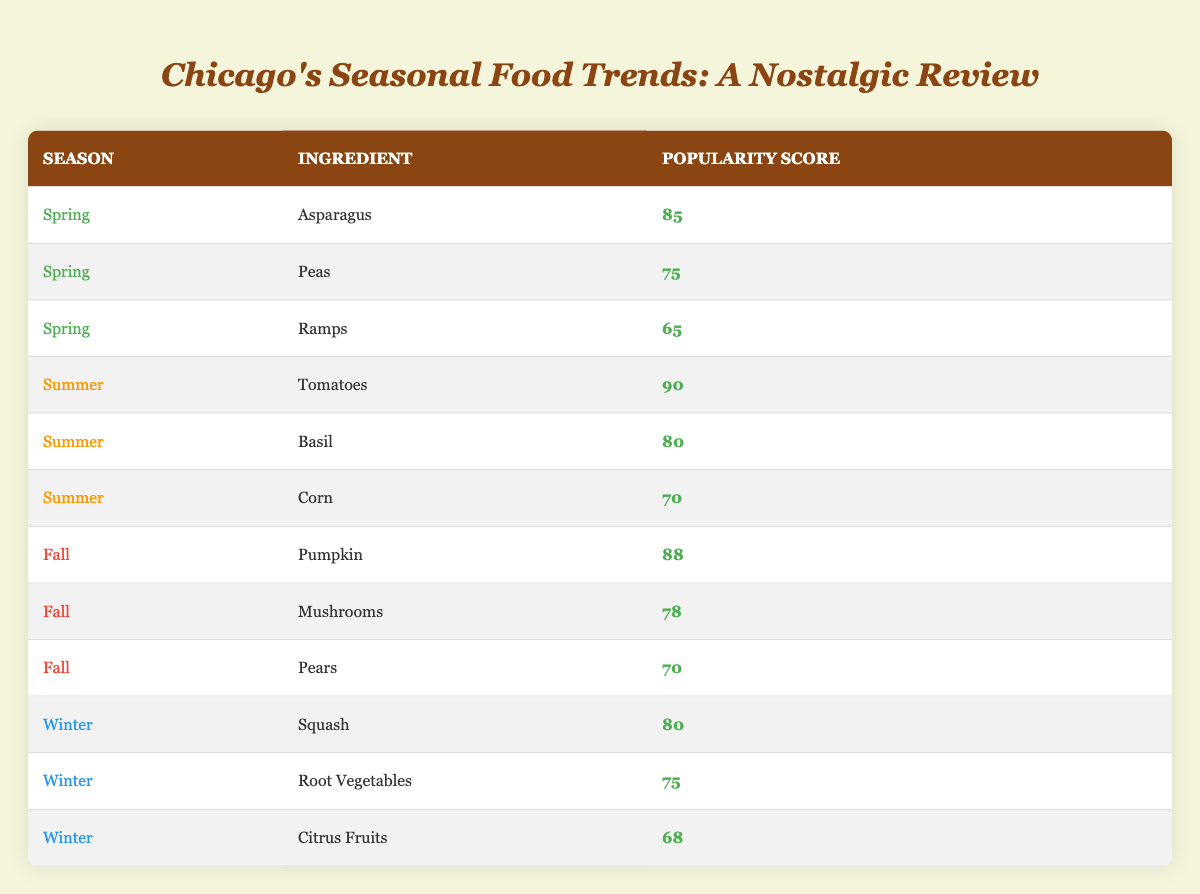What is the highest popularity score among the ingredients listed? The table shows various ingredients with corresponding popularity scores. The highest score is found by scanning the scores listed, where "Tomatoes" has a score of 90, which is the highest in the table.
Answer: 90 Which ingredient has the lowest popularity score in winter? To find the lowest popularity score in winter, examine the scores for the winter ingredients: Squash (80), Root Vegetables (75), and Citrus Fruits (68). The lowest score is associated with "Citrus Fruits" at 68.
Answer: Citrus Fruits What is the average popularity score for fall ingredients? The fall ingredients listed are Pumpkin (88), Mushrooms (78), and Pears (70). To find the average, sum the scores: 88 + 78 + 70 = 236. There are 3 ingredients, so the average is 236 / 3 = 78.67.
Answer: 78.67 Is basil more popular than corn? The popularity score for "Basil" is 80 while for "Corn" it is 70. Comparing the two scores shows that Basil's score is indeed higher than Corn's.
Answer: Yes Which season features the ingredient with a popularity score of 75? Looking through the table, the score of 75 is noted under both "Peas" in spring and "Root Vegetables" in winter. Therefore, two seasons feature ingredients with this score: Spring and Winter.
Answer: Spring and Winter Which ingredient in summer has the second highest popularity score? The summer scores show Tomatoes (90), Basil (80), and Corn (70). The second highest is Basil with a score of 80, as it follows directly after Tomatoes in ranking.
Answer: Basil How many fall ingredients score higher than 70? The scores for fall ingredients are: Pumpkin (88), Mushrooms (78), and Pears (70). Both Pumpkin and Mushrooms have scores higher than 70, totaling two ingredients.
Answer: 2 In which season is asparagus most popular, and what is its score? Asparagus is listed under spring with a popularity score of 85. Therefore, it is most popular in spring with that score.
Answer: Spring, 85 What is the difference in popularity score between the most popular summer and the most popular fall ingredient? The most popular summer ingredient is Tomatoes (90), and the most popular fall ingredient is Pumpkin (88). The difference is calculated as 90 - 88 = 2.
Answer: 2 